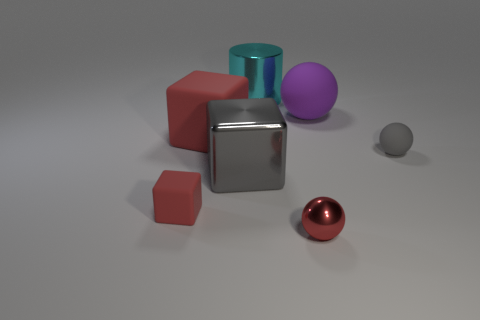Subtract all cylinders. How many objects are left? 6 Add 1 red matte spheres. How many objects exist? 8 Subtract all small shiny spheres. How many spheres are left? 2 Subtract all gray cylinders. How many brown spheres are left? 0 Subtract all brown matte balls. Subtract all gray things. How many objects are left? 5 Add 6 gray matte balls. How many gray matte balls are left? 7 Add 1 large matte blocks. How many large matte blocks exist? 2 Subtract all gray blocks. How many blocks are left? 2 Subtract 0 cyan cubes. How many objects are left? 7 Subtract 1 cylinders. How many cylinders are left? 0 